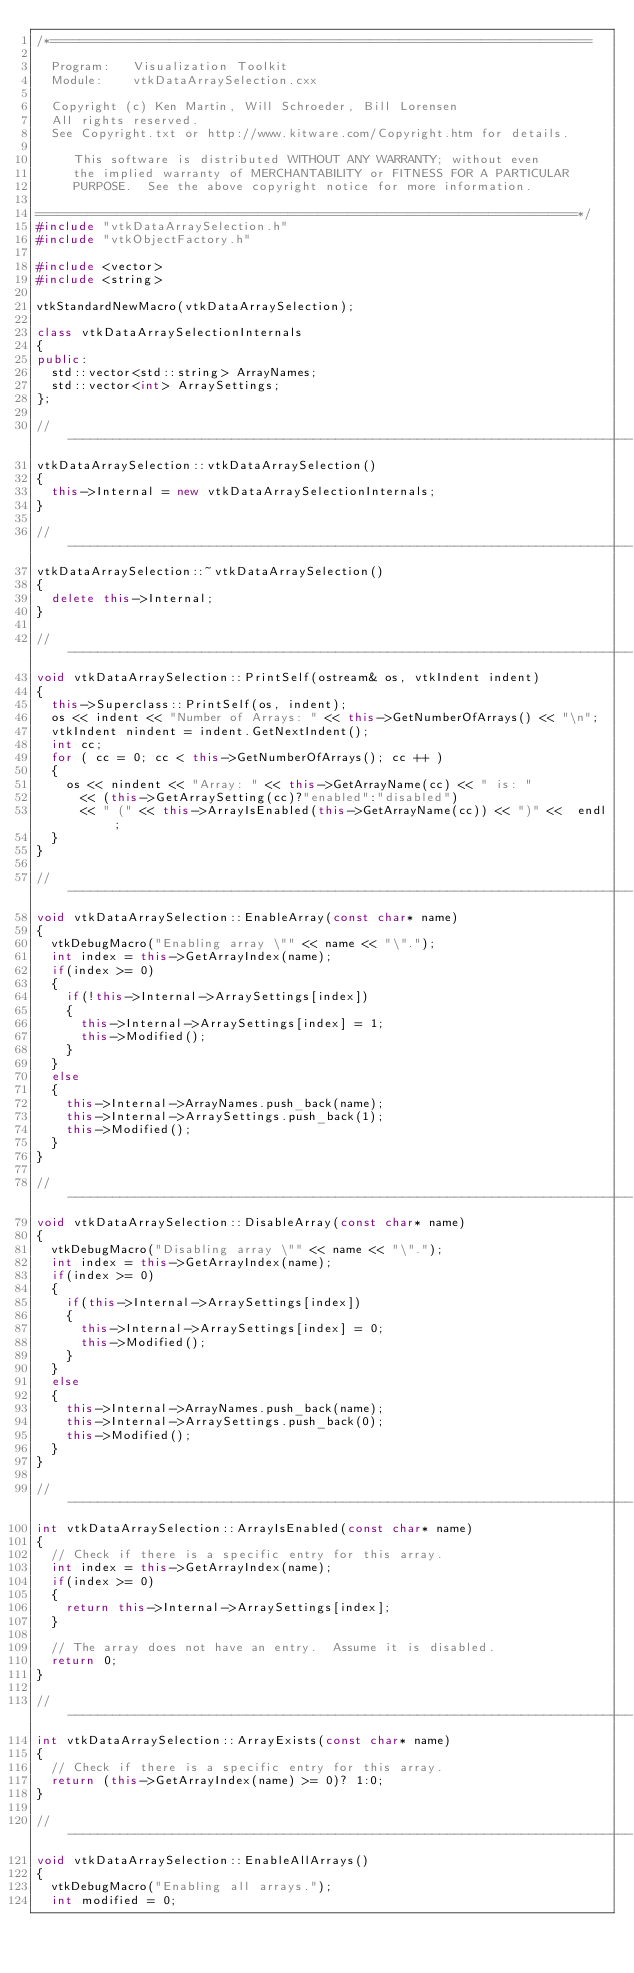Convert code to text. <code><loc_0><loc_0><loc_500><loc_500><_C++_>/*=========================================================================

  Program:   Visualization Toolkit
  Module:    vtkDataArraySelection.cxx

  Copyright (c) Ken Martin, Will Schroeder, Bill Lorensen
  All rights reserved.
  See Copyright.txt or http://www.kitware.com/Copyright.htm for details.

     This software is distributed WITHOUT ANY WARRANTY; without even
     the implied warranty of MERCHANTABILITY or FITNESS FOR A PARTICULAR
     PURPOSE.  See the above copyright notice for more information.

=========================================================================*/
#include "vtkDataArraySelection.h"
#include "vtkObjectFactory.h"

#include <vector>
#include <string>

vtkStandardNewMacro(vtkDataArraySelection);

class vtkDataArraySelectionInternals
{
public:
  std::vector<std::string> ArrayNames;
  std::vector<int> ArraySettings;
};

//----------------------------------------------------------------------------
vtkDataArraySelection::vtkDataArraySelection()
{
  this->Internal = new vtkDataArraySelectionInternals;
}

//----------------------------------------------------------------------------
vtkDataArraySelection::~vtkDataArraySelection()
{
  delete this->Internal;
}

//----------------------------------------------------------------------------
void vtkDataArraySelection::PrintSelf(ostream& os, vtkIndent indent)
{
  this->Superclass::PrintSelf(os, indent);
  os << indent << "Number of Arrays: " << this->GetNumberOfArrays() << "\n";
  vtkIndent nindent = indent.GetNextIndent();
  int cc;
  for ( cc = 0; cc < this->GetNumberOfArrays(); cc ++ )
  {
    os << nindent << "Array: " << this->GetArrayName(cc) << " is: "
      << (this->GetArraySetting(cc)?"enabled":"disabled")
      << " (" << this->ArrayIsEnabled(this->GetArrayName(cc)) << ")" <<  endl;
  }
}

//----------------------------------------------------------------------------
void vtkDataArraySelection::EnableArray(const char* name)
{
  vtkDebugMacro("Enabling array \"" << name << "\".");
  int index = this->GetArrayIndex(name);
  if(index >= 0)
  {
    if(!this->Internal->ArraySettings[index])
    {
      this->Internal->ArraySettings[index] = 1;
      this->Modified();
    }
  }
  else
  {
    this->Internal->ArrayNames.push_back(name);
    this->Internal->ArraySettings.push_back(1);
    this->Modified();
  }
}

//----------------------------------------------------------------------------
void vtkDataArraySelection::DisableArray(const char* name)
{
  vtkDebugMacro("Disabling array \"" << name << "\".");
  int index = this->GetArrayIndex(name);
  if(index >= 0)
  {
    if(this->Internal->ArraySettings[index])
    {
      this->Internal->ArraySettings[index] = 0;
      this->Modified();
    }
  }
  else
  {
    this->Internal->ArrayNames.push_back(name);
    this->Internal->ArraySettings.push_back(0);
    this->Modified();
  }
}

//----------------------------------------------------------------------------
int vtkDataArraySelection::ArrayIsEnabled(const char* name)
{
  // Check if there is a specific entry for this array.
  int index = this->GetArrayIndex(name);
  if(index >= 0)
  {
    return this->Internal->ArraySettings[index];
  }

  // The array does not have an entry.  Assume it is disabled.
  return 0;
}

//----------------------------------------------------------------------------
int vtkDataArraySelection::ArrayExists(const char* name)
{
  // Check if there is a specific entry for this array.
  return (this->GetArrayIndex(name) >= 0)? 1:0;
}

//----------------------------------------------------------------------------
void vtkDataArraySelection::EnableAllArrays()
{
  vtkDebugMacro("Enabling all arrays.");
  int modified = 0;</code> 